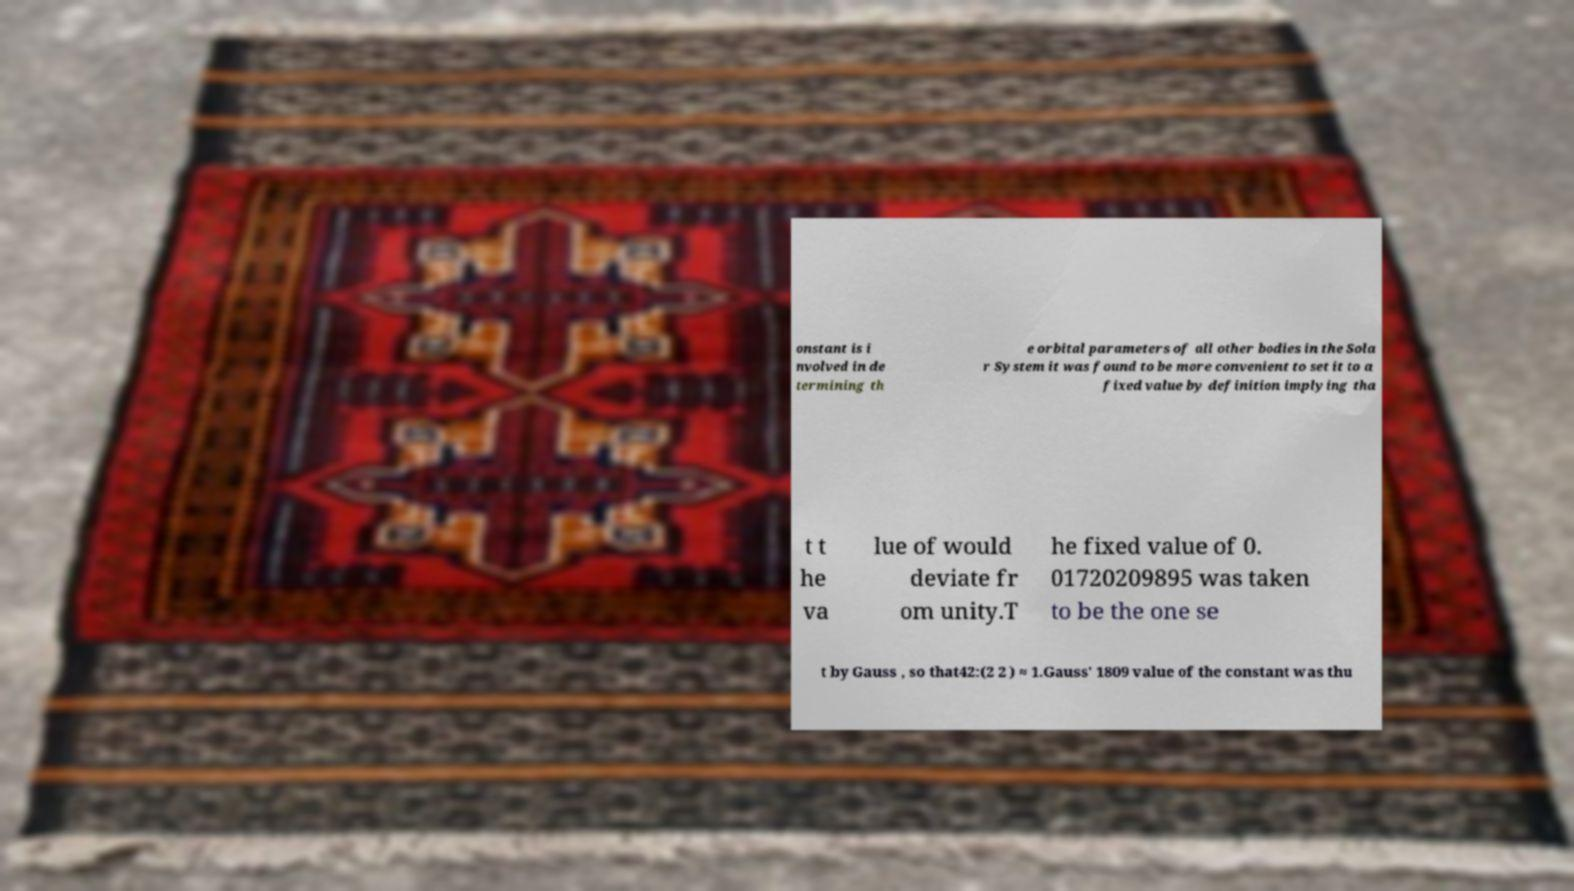Could you extract and type out the text from this image? onstant is i nvolved in de termining th e orbital parameters of all other bodies in the Sola r System it was found to be more convenient to set it to a fixed value by definition implying tha t t he va lue of would deviate fr om unity.T he fixed value of 0. 01720209895 was taken to be the one se t by Gauss , so that42:(2 2 ) ≈ 1.Gauss' 1809 value of the constant was thu 